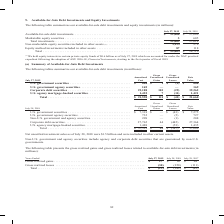From Cisco Systems's financial document, Which years does the table provide information for the company's available-for-sale debt investments and equity investments? The document shows two values: 2019 and 2018. From the document: "July 27, 2019 July 28, 2018 Available-for-sale debt investments� � � � � � � � � � � � � � � � � � � � � � � � � July 27, 2019 July 28, 2018 Available..." Also, What was the Marketable equity securities in 2018? According to the financial document, 605 (in millions). The relevant text states: "� � � � � � � � � � � � � � � � � � � � � � � � 3 605 Total investments � � � � � � � � � � � � � � � � � � � � � � � � � � � � � � � � � � � � � � � � �..." Also, What were the total investments in 2019? According to the financial document, 21,663 (in millions). The relevant text states: "� � � � � � � � � � � � � � � � � � � � � � � � � 21,663 37,614 Non-marketable equity securities included in other assets (1) � � � � � � � � � � � � � � �..." Also, can you calculate: What was the change in the Equity method investments included in other assets between 2018 and 2019? Based on the calculation: 87-118, the result is -31 (in millions). This is based on the information: "� � � � � � � � � � � � � � � � � � � � � � � 87 118 Total � � � � � � � � � � � � � � � � � � � � � � � � � � � � � � � � � � � � � � � � � � � � � � � � � � � � � � � � � � � � � � � � � � � � � � �..." The key data points involved are: 118, 87. Also, How many years did total investments exceed $30,000 million? Based on the analysis, there are 1 instances. The counting process: 2018. Also, can you calculate: What was the percentage change in the total available-for-sale debt investments and equity investments between 2018 and 2019? To answer this question, I need to perform calculations using the financial data. The calculation is: (22,863-38,710)/38,710, which equals -40.94 (percentage). This is based on the information: "� � � � � � � � � � � � � � � � � � � $ 22,863 $ 38,710 � � � � � � � � � � � � � � � � � � � � � � � � $ 22,863 $ 38,710..." The key data points involved are: 22,863, 38,710. 